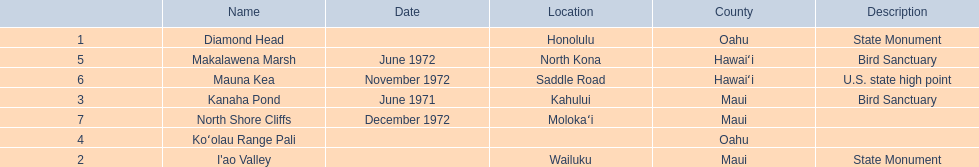Which national natural landmarks in hawaii are in oahu county? Diamond Head, Koʻolau Range Pali. Of these landmarks, which one is listed without a location? Koʻolau Range Pali. 